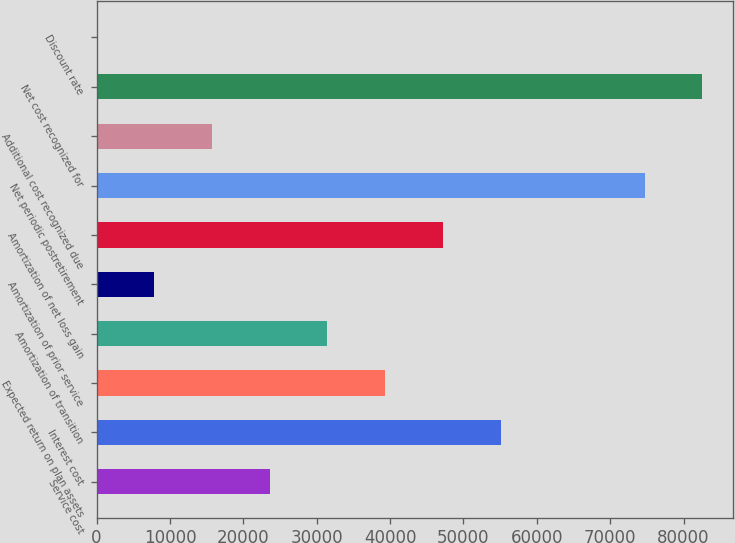<chart> <loc_0><loc_0><loc_500><loc_500><bar_chart><fcel>Service cost<fcel>Interest cost<fcel>Expected return on plan assets<fcel>Amortization of transition<fcel>Amortization of prior service<fcel>Amortization of net loss gain<fcel>Net periodic postretirement<fcel>Additional cost recognized due<fcel>Net cost recognized for<fcel>Discount rate<nl><fcel>23578.5<fcel>55060<fcel>39293.5<fcel>31436<fcel>7863.5<fcel>47151<fcel>74690<fcel>15721<fcel>82547.5<fcel>6<nl></chart> 